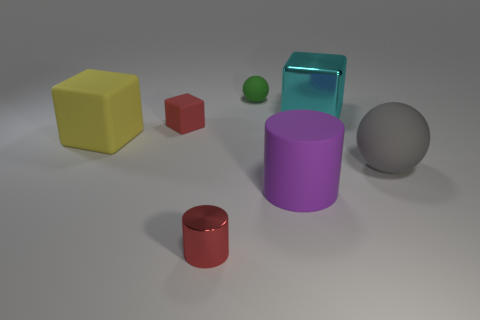Add 3 small blue metal cylinders. How many objects exist? 10 Subtract all cylinders. How many objects are left? 5 Add 6 small red rubber objects. How many small red rubber objects are left? 7 Add 5 small green spheres. How many small green spheres exist? 6 Subtract 1 red cylinders. How many objects are left? 6 Subtract all big shiny balls. Subtract all large yellow matte cubes. How many objects are left? 6 